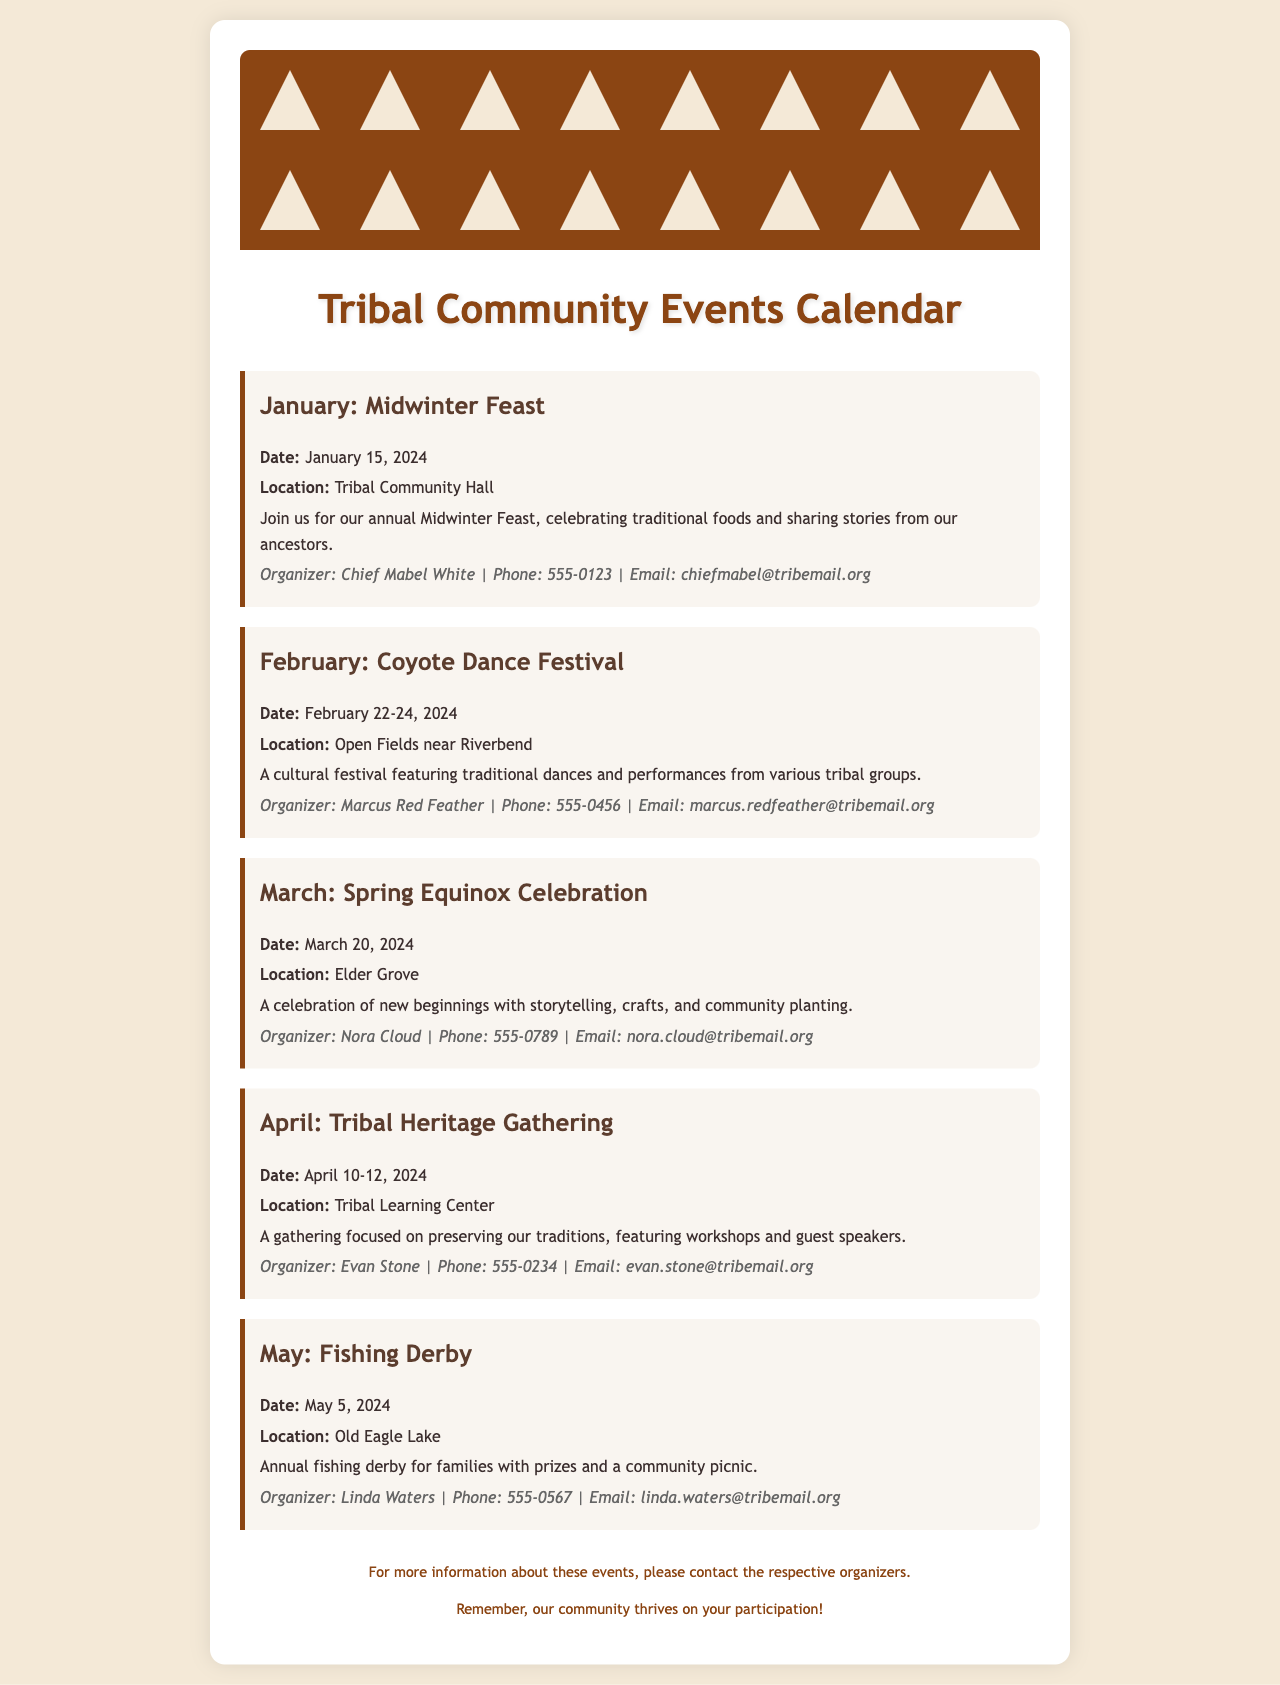What is the date of the Midwinter Feast? The date of the Midwinter Feast is provided in the document as January 15, 2024.
Answer: January 15, 2024 Who is the organizer of the Coyote Dance Festival? The document states that the Coyote Dance Festival is organized by Marcus Red Feather.
Answer: Marcus Red Feather Where will the Fishing Derby be held? The location for the Fishing Derby is specified in the document as Old Eagle Lake.
Answer: Old Eagle Lake What activities are featured in the Spring Equinox Celebration? The document mentions storytelling, crafts, and community planting as activities for the Spring Equinox Celebration.
Answer: Storytelling, crafts, community planting How many days does the Tribal Heritage Gathering last? The duration of the Tribal Heritage Gathering is mentioned as April 10-12, 2024, which indicates it lasts for 3 days.
Answer: 3 days What type of event is scheduled for May? The document describes the event scheduled for May as a fishing derby.
Answer: Fishing Derby Who can be contacted for information about the Tribal Heritage Gathering? The document lists Evan Stone as the organizer for the Tribal Heritage Gathering, and he can be contacted for more information.
Answer: Evan Stone When is the Coyote Dance Festival taking place? The document specifies that the Coyote Dance Festival takes place from February 22-24, 2024.
Answer: February 22-24, 2024 What is the main focus of the Tribal Heritage Gathering? The document indicates that the main focus of the Tribal Heritage Gathering is preserving traditions.
Answer: Preserving traditions 